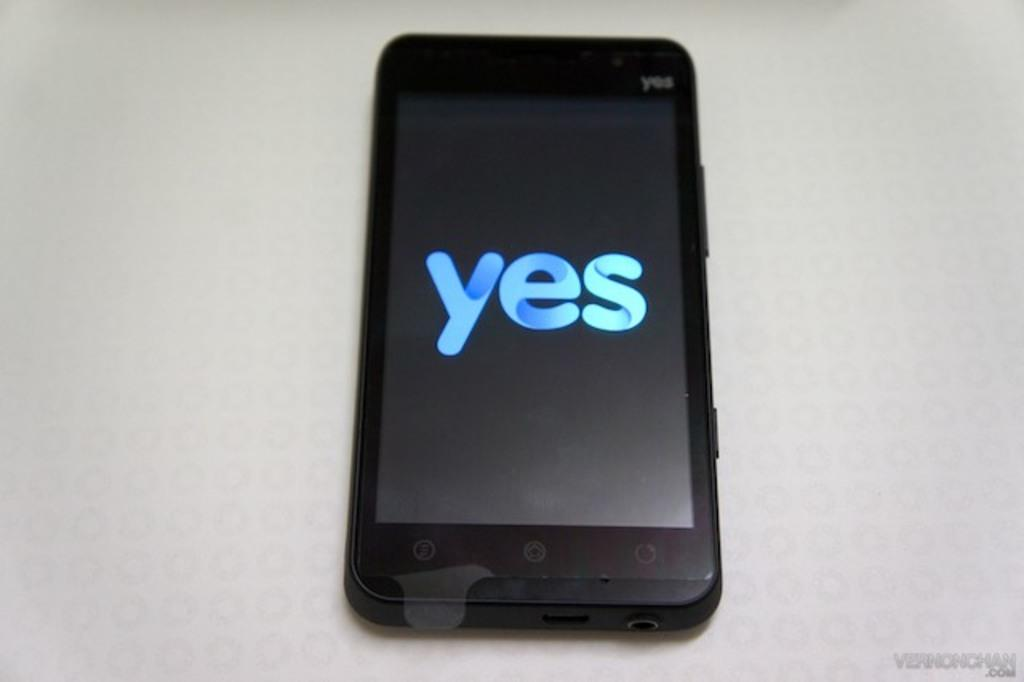<image>
Share a concise interpretation of the image provided. A black cellphone with a warped protective cover has the word yes displayed. 